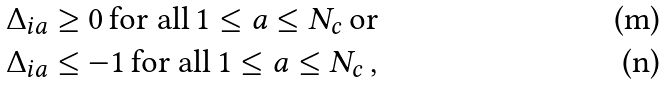Convert formula to latex. <formula><loc_0><loc_0><loc_500><loc_500>& \Delta _ { i a } \geq 0 \, \text {for all} \, 1 \leq a \leq N _ { c } \, \text {or} \\ & \Delta _ { i a } \leq - 1 \, \text {for all} \, 1 \leq a \leq N _ { c } \, ,</formula> 